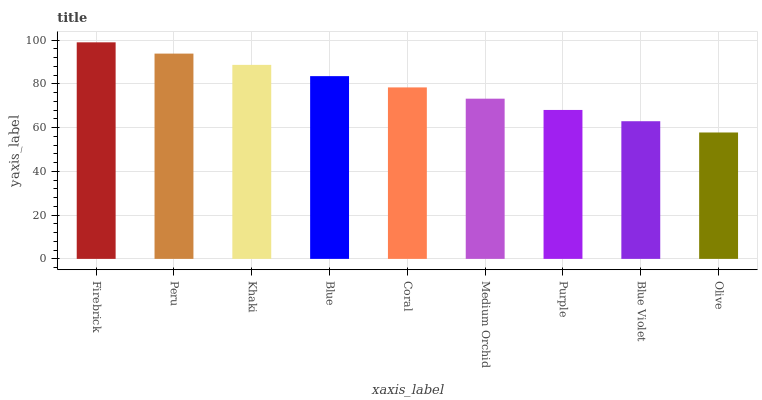Is Olive the minimum?
Answer yes or no. Yes. Is Firebrick the maximum?
Answer yes or no. Yes. Is Peru the minimum?
Answer yes or no. No. Is Peru the maximum?
Answer yes or no. No. Is Firebrick greater than Peru?
Answer yes or no. Yes. Is Peru less than Firebrick?
Answer yes or no. Yes. Is Peru greater than Firebrick?
Answer yes or no. No. Is Firebrick less than Peru?
Answer yes or no. No. Is Coral the high median?
Answer yes or no. Yes. Is Coral the low median?
Answer yes or no. Yes. Is Firebrick the high median?
Answer yes or no. No. Is Blue Violet the low median?
Answer yes or no. No. 